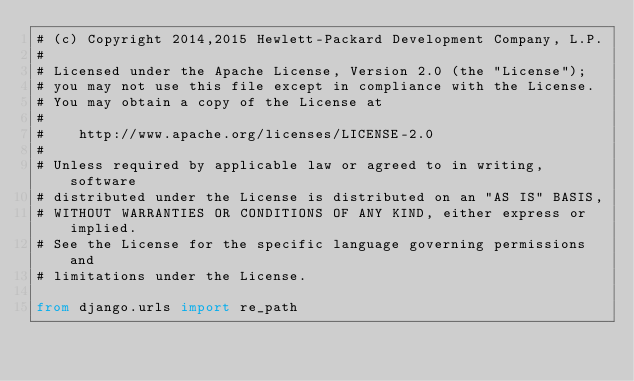<code> <loc_0><loc_0><loc_500><loc_500><_Python_># (c) Copyright 2014,2015 Hewlett-Packard Development Company, L.P.
#
# Licensed under the Apache License, Version 2.0 (the "License");
# you may not use this file except in compliance with the License.
# You may obtain a copy of the License at
#
#    http://www.apache.org/licenses/LICENSE-2.0
#
# Unless required by applicable law or agreed to in writing, software
# distributed under the License is distributed on an "AS IS" BASIS,
# WITHOUT WARRANTIES OR CONDITIONS OF ANY KIND, either express or implied.
# See the License for the specific language governing permissions and
# limitations under the License.

from django.urls import re_path
</code> 